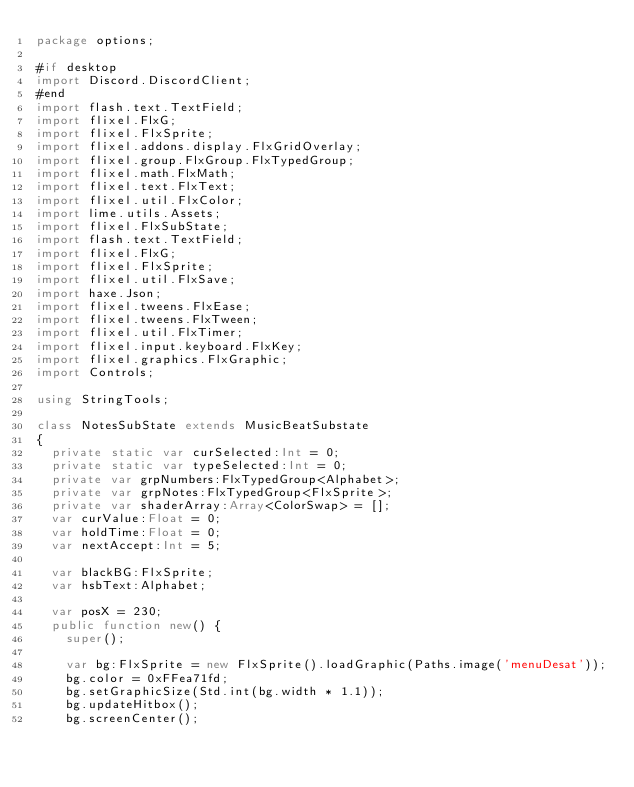<code> <loc_0><loc_0><loc_500><loc_500><_Haxe_>package options;

#if desktop
import Discord.DiscordClient;
#end
import flash.text.TextField;
import flixel.FlxG;
import flixel.FlxSprite;
import flixel.addons.display.FlxGridOverlay;
import flixel.group.FlxGroup.FlxTypedGroup;
import flixel.math.FlxMath;
import flixel.text.FlxText;
import flixel.util.FlxColor;
import lime.utils.Assets;
import flixel.FlxSubState;
import flash.text.TextField;
import flixel.FlxG;
import flixel.FlxSprite;
import flixel.util.FlxSave;
import haxe.Json;
import flixel.tweens.FlxEase;
import flixel.tweens.FlxTween;
import flixel.util.FlxTimer;
import flixel.input.keyboard.FlxKey;
import flixel.graphics.FlxGraphic;
import Controls;

using StringTools;

class NotesSubState extends MusicBeatSubstate
{
	private static var curSelected:Int = 0;
	private static var typeSelected:Int = 0;
	private var grpNumbers:FlxTypedGroup<Alphabet>;
	private var grpNotes:FlxTypedGroup<FlxSprite>;
	private var shaderArray:Array<ColorSwap> = [];
	var curValue:Float = 0;
	var holdTime:Float = 0;
	var nextAccept:Int = 5;

	var blackBG:FlxSprite;
	var hsbText:Alphabet;

	var posX = 230;
	public function new() {
		super();
		
		var bg:FlxSprite = new FlxSprite().loadGraphic(Paths.image('menuDesat'));
		bg.color = 0xFFea71fd;
		bg.setGraphicSize(Std.int(bg.width * 1.1));
		bg.updateHitbox();
		bg.screenCenter();</code> 